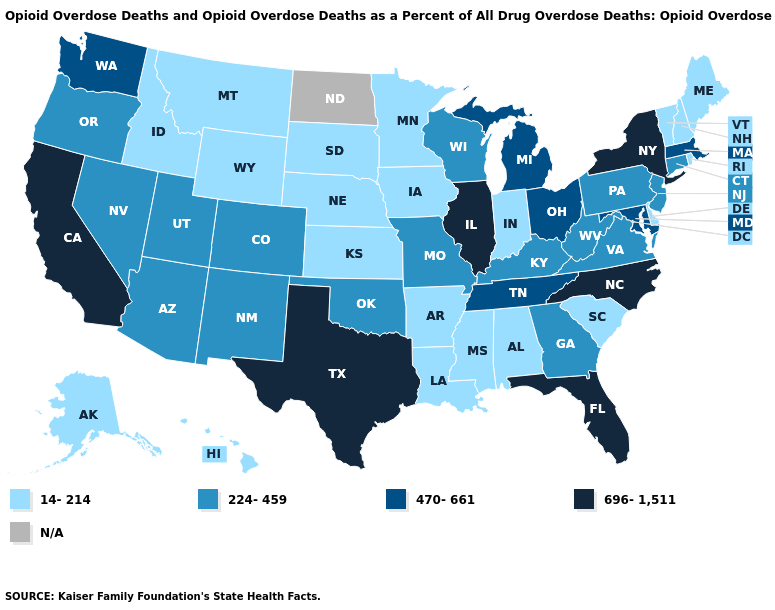What is the value of New Jersey?
Quick response, please. 224-459. Is the legend a continuous bar?
Concise answer only. No. Among the states that border Delaware , which have the lowest value?
Give a very brief answer. New Jersey, Pennsylvania. Among the states that border North Carolina , which have the highest value?
Keep it brief. Tennessee. Name the states that have a value in the range 224-459?
Concise answer only. Arizona, Colorado, Connecticut, Georgia, Kentucky, Missouri, Nevada, New Jersey, New Mexico, Oklahoma, Oregon, Pennsylvania, Utah, Virginia, West Virginia, Wisconsin. Among the states that border Mississippi , which have the highest value?
Be succinct. Tennessee. Does New Mexico have the lowest value in the USA?
Short answer required. No. Name the states that have a value in the range N/A?
Keep it brief. North Dakota. What is the lowest value in the West?
Short answer required. 14-214. Name the states that have a value in the range 14-214?
Short answer required. Alabama, Alaska, Arkansas, Delaware, Hawaii, Idaho, Indiana, Iowa, Kansas, Louisiana, Maine, Minnesota, Mississippi, Montana, Nebraska, New Hampshire, Rhode Island, South Carolina, South Dakota, Vermont, Wyoming. What is the highest value in the Northeast ?
Short answer required. 696-1,511. Does the map have missing data?
Quick response, please. Yes. Among the states that border Pennsylvania , does New York have the highest value?
Give a very brief answer. Yes. 